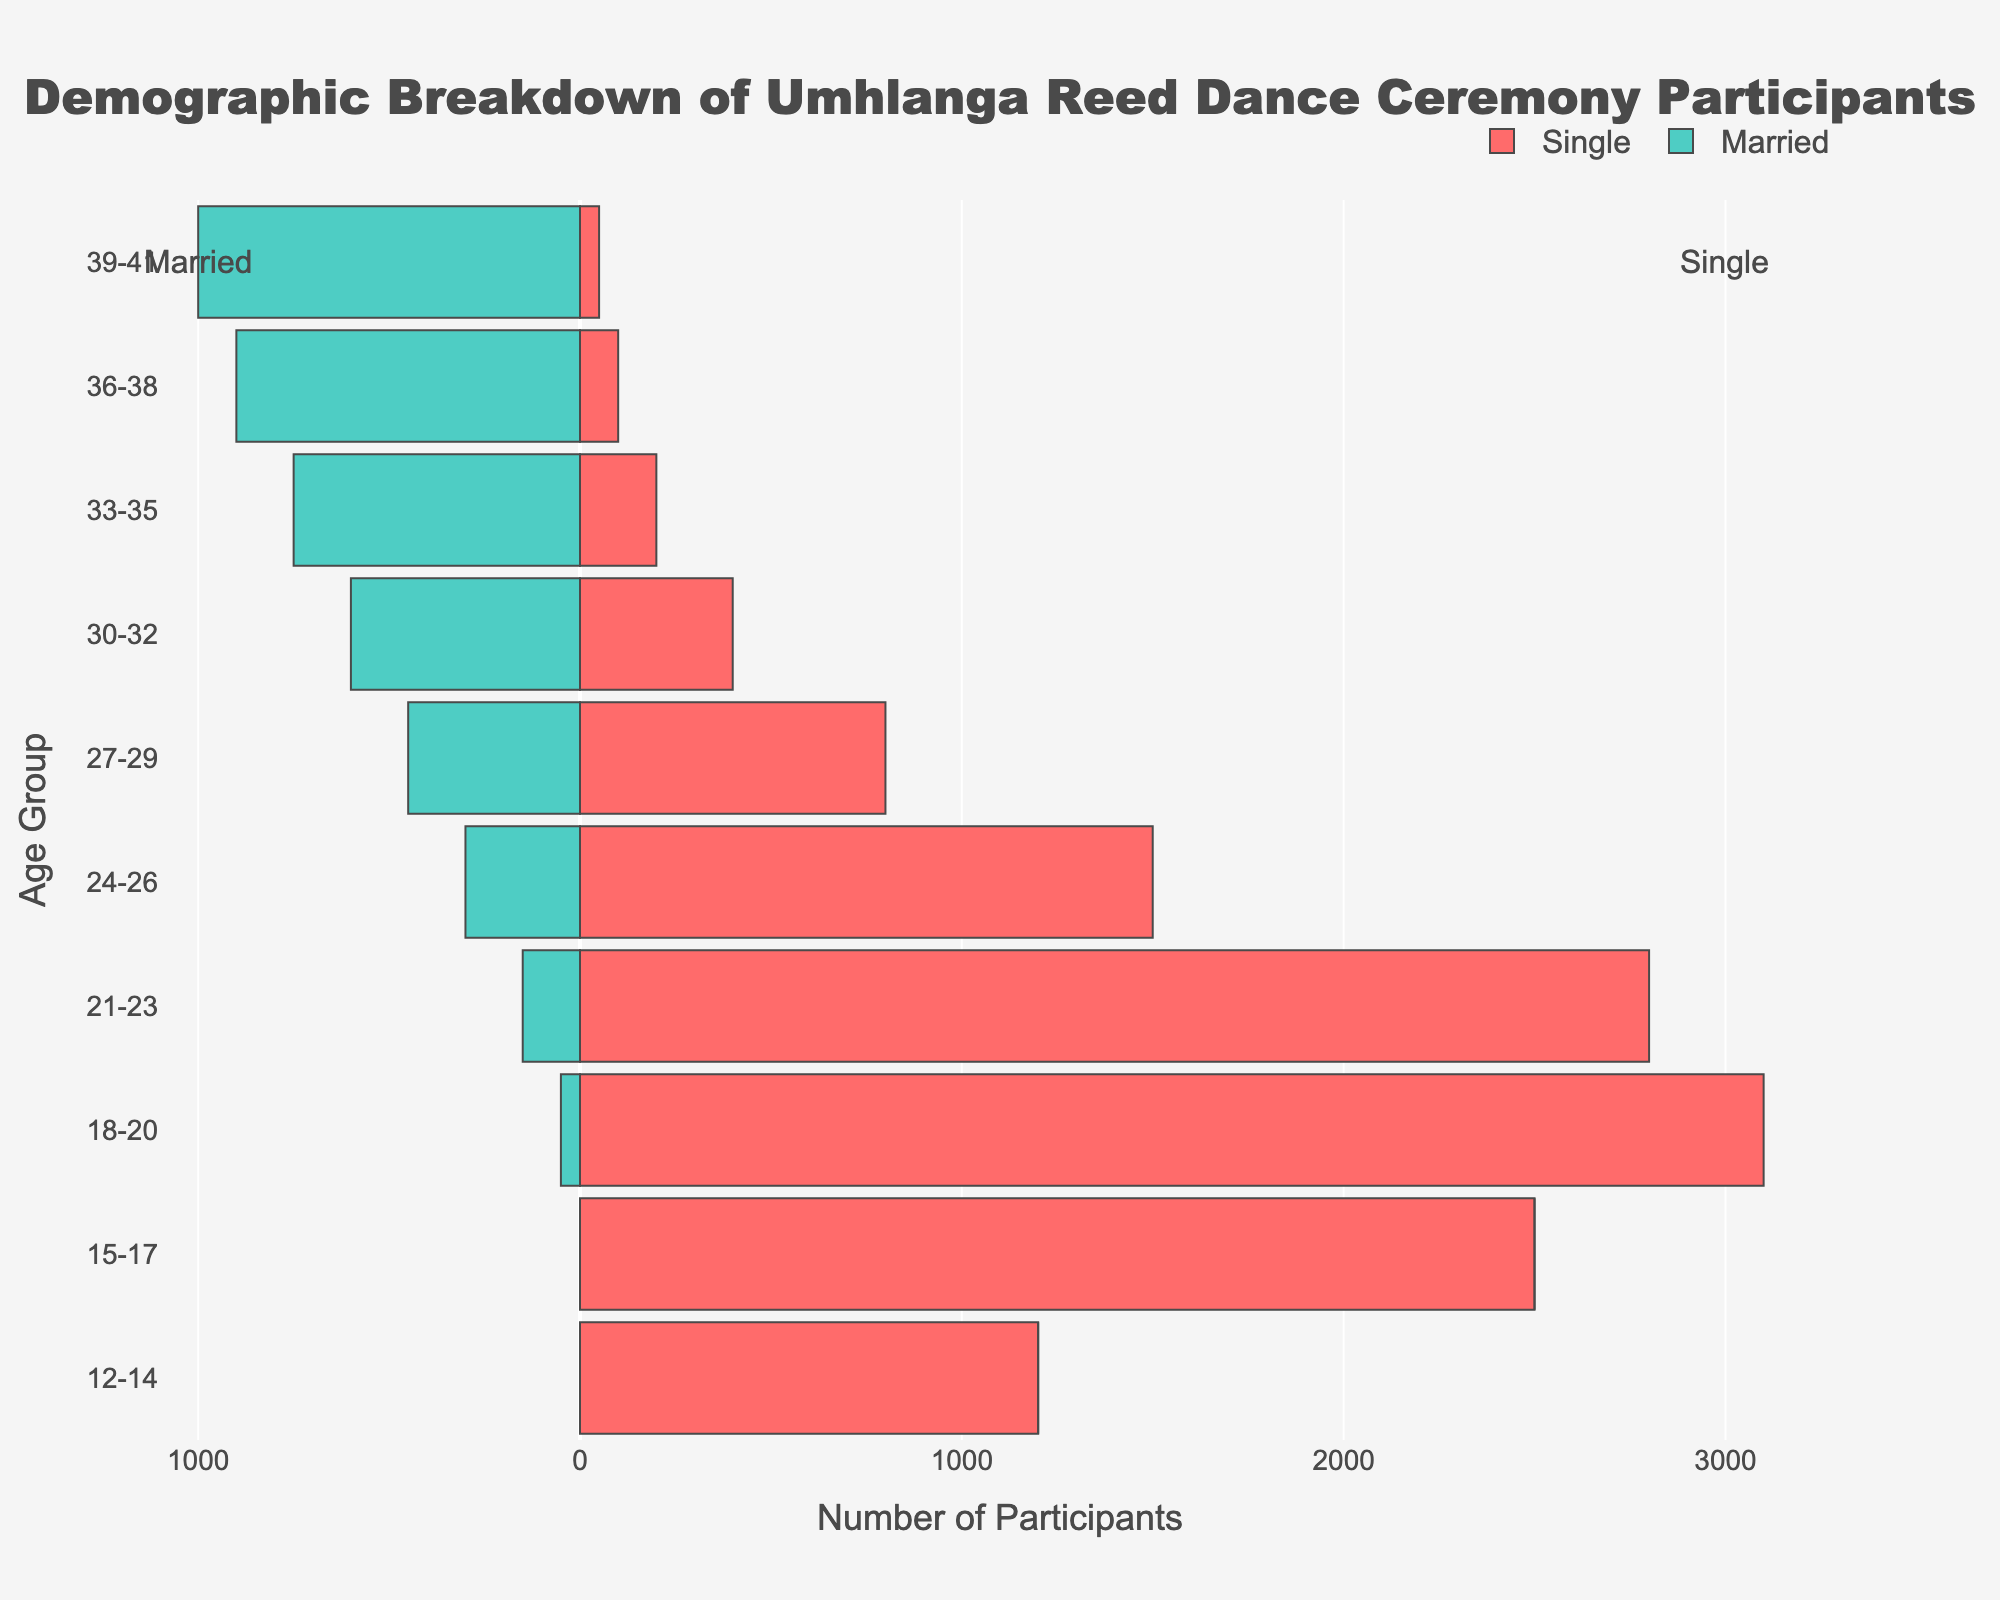Which age group has the highest number of single participants? To find the age group with the highest number of single participants, look at the "Single" bar in the age categories and identify the longest bar. The age group 18-20 has the longest bar with 3100 participants.
Answer: 18-20 How many married participants are there in the 24-26 age group? Look at the "Married" bar for the age group 24-26, represented on the left side of the pyramid. There are 300 married participants in this age group.
Answer: 300 What is the range of ages that the population pyramid covers? The population pyramid starts from age group 12-14 and ends with age group 39-41. Thus, it covers ages from 12 to 41 years old.
Answer: 12-41 Which age group has the most balanced number of single and married participants? Find the age group where the length of the bars for "Single" and "Married" are closest to each other. The 36-38 age group has 100 single participants and 900 married participants, but age group 27-29 with 800 single and 450 married participants is more balanced.
Answer: 27-29 Compare the number of single and married participants in the age group 30-32. In the age group 30-32, there are 400 single participants and 600 married participants. The difference is 600 (married) - 400 (single) = 200.
Answer: 200 What is the total number of single participants across all age groups? Sum the number of single participants in all age groups: 1200 + 2500 + 3100 + 2800 + 1500 + 800 + 400 + 200 + 100 + 50 = 12850.
Answer: 12850 Which age group has the highest proportion of married participants? The age group with the maximum number of married participants would have the highest bar on the left side of the pyramid. Age group 39-41 has 1000 married participants, which is the highest.
Answer: 39-41 In the age group 21-23, how many more single participants are there than married participants? For the age group 21-23, there are 2800 single participants and 150 married participants. The difference is 2800 - 150 = 2650.
Answer: 2650 Is the number of single participants consistently decreasing with age? Examine the count of single participants from the youngest to the oldest age groups. It starts high at 1200, increases to a peak of 3100 at age 18-20, and then decreases consistently thereafter.
Answer: Yes 